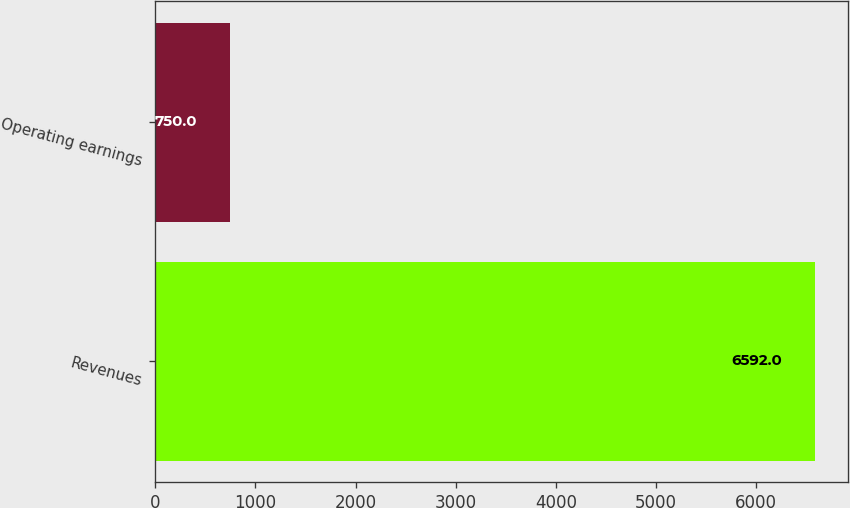Convert chart. <chart><loc_0><loc_0><loc_500><loc_500><bar_chart><fcel>Revenues<fcel>Operating earnings<nl><fcel>6592<fcel>750<nl></chart> 